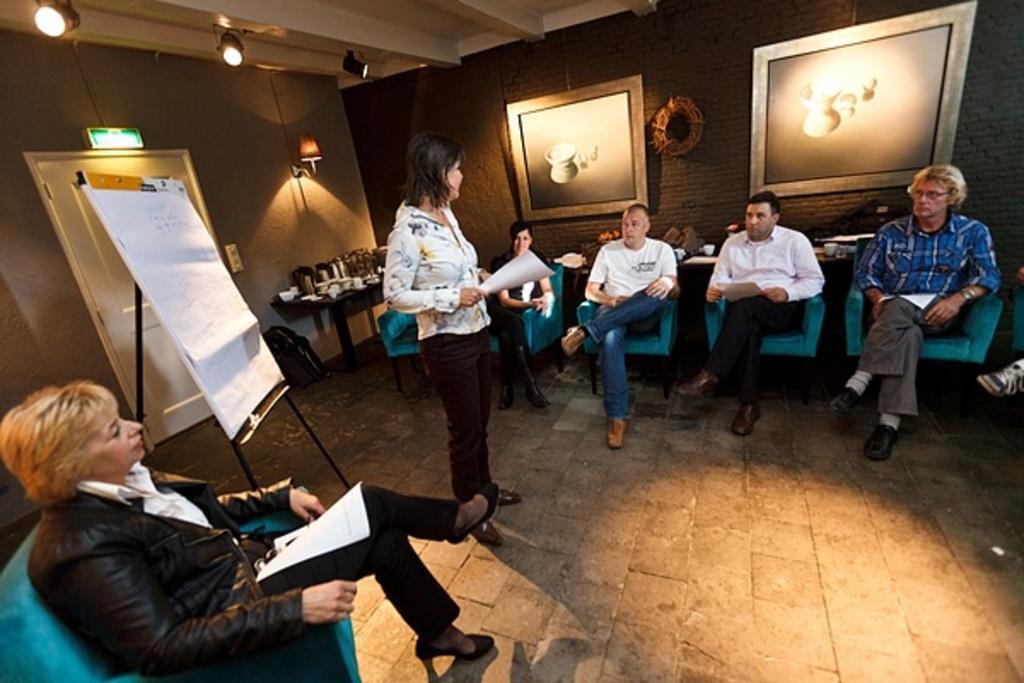In one or two sentences, can you explain what this image depicts? In the foreground of this picture, there is a woman in black dress sitting on a sofa on the left bottom corner and also there are few persons sitting on the sofa and a woman standing in the center by holding a paper in her hand. In the background, there is a wallboard, jars on the table, lights, frames, a door and the ceiling. 